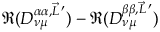Convert formula to latex. <formula><loc_0><loc_0><loc_500><loc_500>\Re ( D _ { \nu \mu } ^ { \alpha \alpha , \vec { L } \, ^ { \prime } } ) - \Re ( D _ { \nu \mu } ^ { \beta \beta , \vec { L } \, ^ { \prime } } )</formula> 